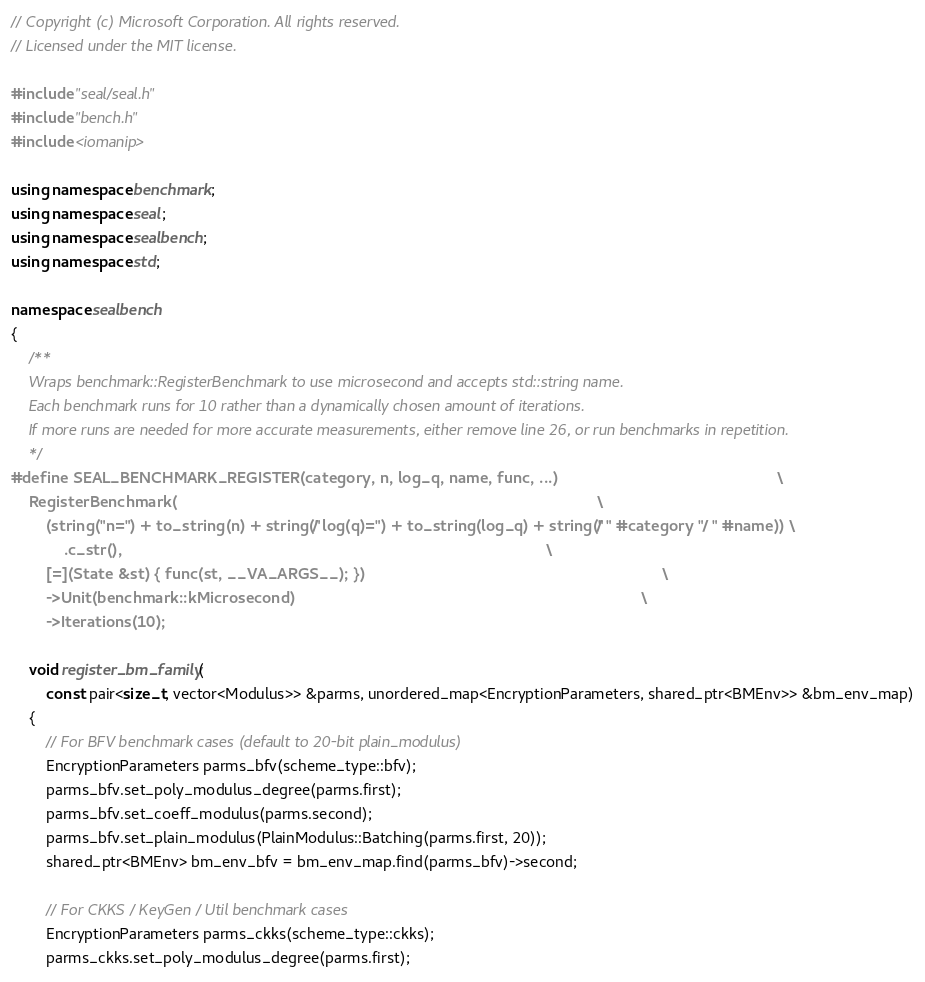<code> <loc_0><loc_0><loc_500><loc_500><_C++_>// Copyright (c) Microsoft Corporation. All rights reserved.
// Licensed under the MIT license.

#include "seal/seal.h"
#include "bench.h"
#include <iomanip>

using namespace benchmark;
using namespace seal;
using namespace sealbench;
using namespace std;

namespace sealbench
{
    /**
    Wraps benchmark::RegisterBenchmark to use microsecond and accepts std::string name.
    Each benchmark runs for 10 rather than a dynamically chosen amount of iterations.
    If more runs are needed for more accurate measurements, either remove line 26, or run benchmarks in repetition.
    */
#define SEAL_BENCHMARK_REGISTER(category, n, log_q, name, func, ...)                                                  \
    RegisterBenchmark(                                                                                                \
        (string("n=") + to_string(n) + string(" / log(q)=") + to_string(log_q) + string(" / " #category " / " #name)) \
            .c_str(),                                                                                                 \
        [=](State &st) { func(st, __VA_ARGS__); })                                                                    \
        ->Unit(benchmark::kMicrosecond)                                                                               \
        ->Iterations(10);

    void register_bm_family(
        const pair<size_t, vector<Modulus>> &parms, unordered_map<EncryptionParameters, shared_ptr<BMEnv>> &bm_env_map)
    {
        // For BFV benchmark cases (default to 20-bit plain_modulus)
        EncryptionParameters parms_bfv(scheme_type::bfv);
        parms_bfv.set_poly_modulus_degree(parms.first);
        parms_bfv.set_coeff_modulus(parms.second);
        parms_bfv.set_plain_modulus(PlainModulus::Batching(parms.first, 20));
        shared_ptr<BMEnv> bm_env_bfv = bm_env_map.find(parms_bfv)->second;

        // For CKKS / KeyGen / Util benchmark cases
        EncryptionParameters parms_ckks(scheme_type::ckks);
        parms_ckks.set_poly_modulus_degree(parms.first);</code> 